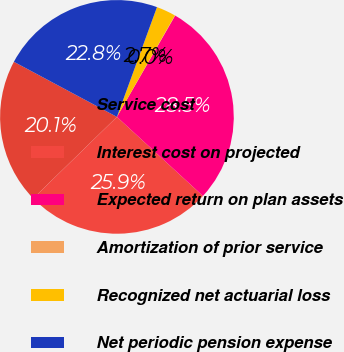Convert chart to OTSL. <chart><loc_0><loc_0><loc_500><loc_500><pie_chart><fcel>Service cost<fcel>Interest cost on projected<fcel>Expected return on plan assets<fcel>Amortization of prior service<fcel>Recognized net actuarial loss<fcel>Net periodic pension expense<nl><fcel>20.1%<fcel>25.88%<fcel>28.53%<fcel>0.04%<fcel>2.69%<fcel>22.75%<nl></chart> 